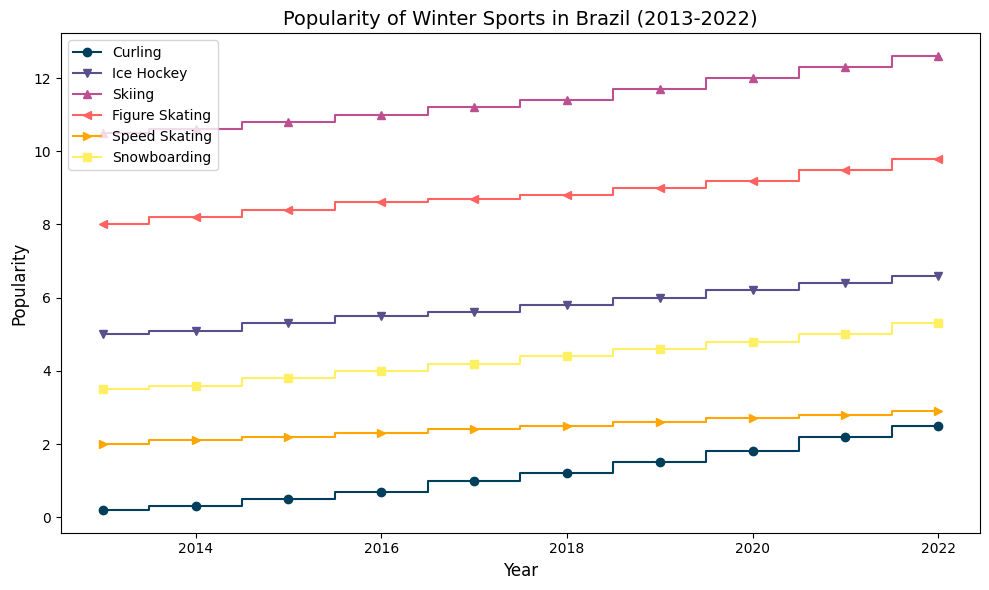What's the trend in the popularity of curling from 2013 to 2022? Analyze the step plot for curling (mid-step line with markers). Observe the incline of the line, which steadily rises year by year from 0.2 in 2013 to 2.5 in 2022, indicating increasing popularity.
Answer: Increasing trend Which winter sport had the highest popularity in 2013? Observe the starting points of all lines in 2013. Compare the values, and note that Skiing has the highest value at 10.5.
Answer: Skiing How did the popularity of Figure Skating change from 2013 to 2022? Look at the mid-step line with markers for Figure Skating. Note that the popularity increased from 8.0 in 2013 to 9.8 in 2022.
Answer: Increased Which sport saw the most significant increase in popularity from 2013 to 2022? Calculate the difference between 2022 and 2013 values for each sport. Curling increased the most (+2.3).
Answer: Curling What is the difference in popularity between Ice Hockey and Speed Skating in 2022? Observe the values for Ice Hockey (6.6) and Speed Skating (2.9) in 2022. Subtract the popularity of Speed Skating from Ice Hockey (6.6 - 2.9).
Answer: 3.7 In which year did Curling surpass 1.0 in popularity? Follow the mid-step line for Curling until it crosses 1.0. This occurs between 2016 (0.7) and 2017 (1.0).
Answer: 2017 How does the popularity of Speed Skating compare to Snowboarding in 2019? Compare the values in 2019: Speed Skating (2.6) and Snowboarding (4.6). Snowboarding is more popular.
Answer: Snowboarding is more popular If you average the popularity values of all sports in 2020, what would the result be? Sum the values for 2020: (1.8 + 6.2 + 12.0 + 9.2 + 2.7 + 4.8 = 36.7). Divide by 6 (number of sports). The result is 36.7 / 6.
Answer: 6.12 What color represents Curling on the plot? Identify the color of the first mid-step line with markers. The first color used is a shade of blue.
Answer: Blue Between which years did Skiing experience the smallest increase in popularity? Calculate yearly increases for Skiing and identify the smallest increase. The smallest increase is from 2019 to 2020 (0.3).
Answer: 2019 to 2020 